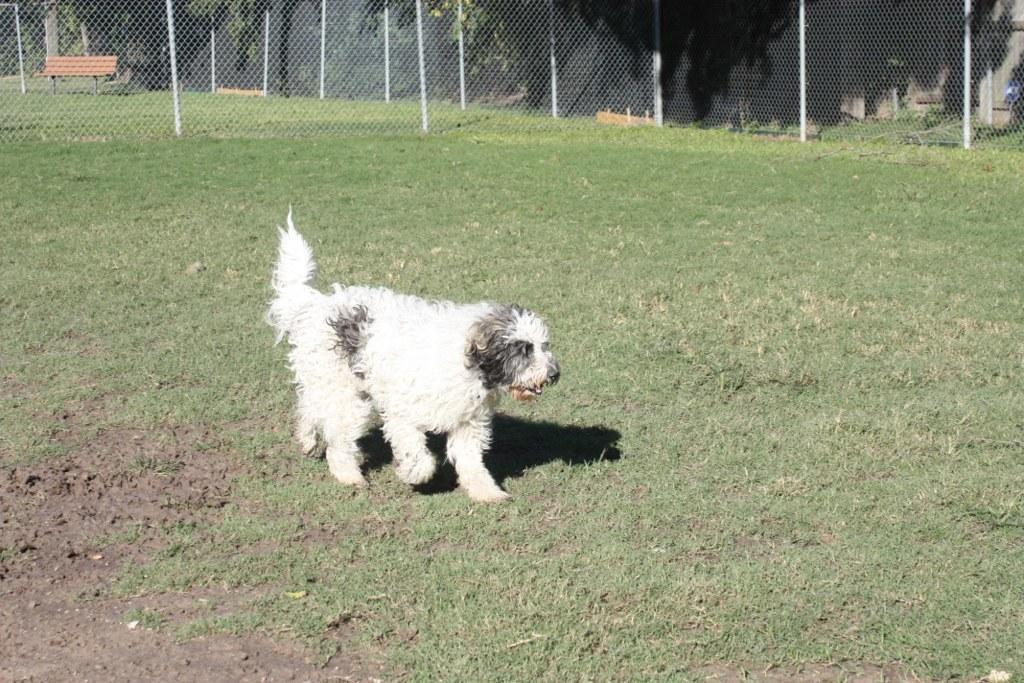In one or two sentences, can you explain what this image depicts? In this picture I can see there is a dog, it has white and black fur. It is walking on the grass, there is soil on the left side. There is a fence in the backdrop, there is a wooden bench, trees and it looks like there is a building on the right side backdrop of the image. 